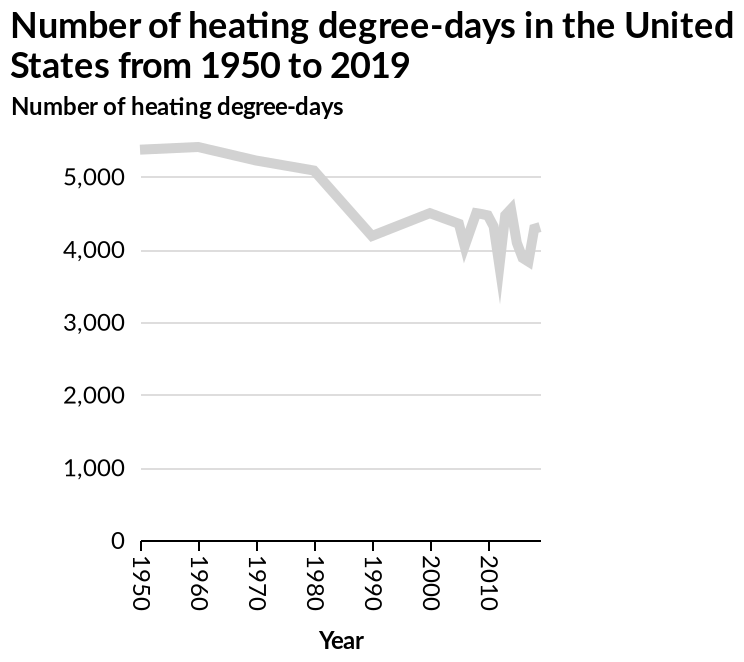<image>
What is the variable plotted on the y-axis?  The variable plotted on the y-axis is the Number of heating degree-days. What does the term "heating degree-days" refer to? "Heating degree-days" is a measure of the amount of heating needed in a specific location over a certain period of time. It takes into account the difference between the average outdoor temperature and a base temperature, typically 65°F, and is used to estimate energy consumption for heating purposes. What kind of changes have occurred in the number of days within each decade?  There have been some sharp changes in the number of days within each decade. Are the changes in the number of days consistent or irregular?  The changes in the number of days are irregular, with some sharp variations within each decade. Are the changes in the number of days regular, with no sharp variations within each decade? No. The changes in the number of days are irregular, with some sharp variations within each decade. 